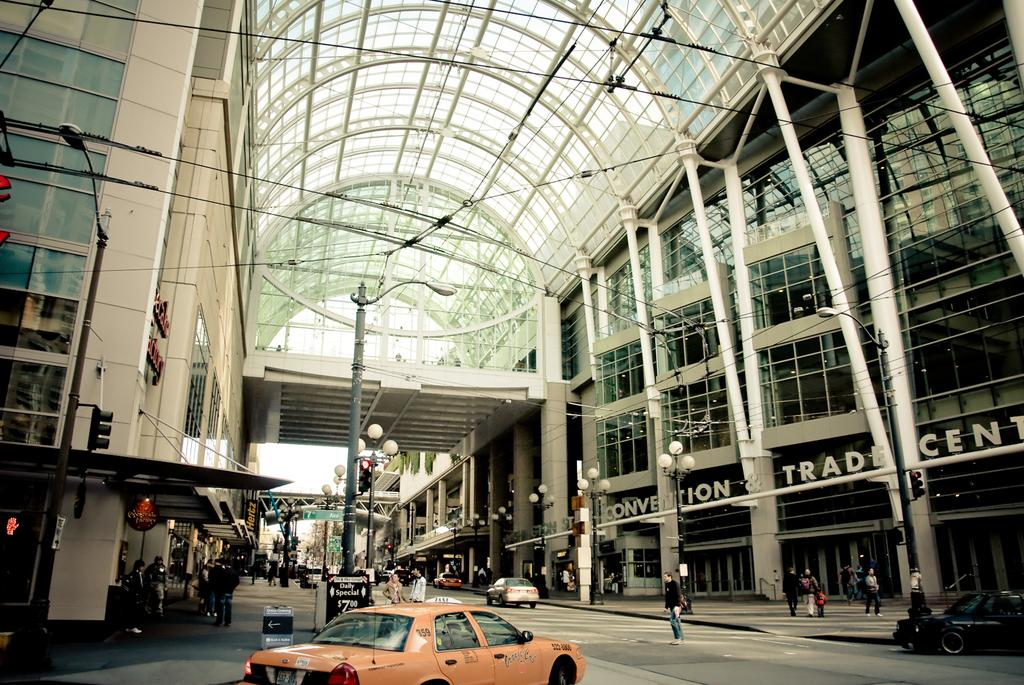What type of structures are present in the image? There are buildings with roofs in the image. What are the people doing under the roofs? People are walking under the roofs. What else can be seen on the ground in the image? There are vehicles visible on the road. What type of soap is being used by the people walking under the roofs in the image? There is no soap present in the image, as the people are walking under the roofs and not washing anything. 